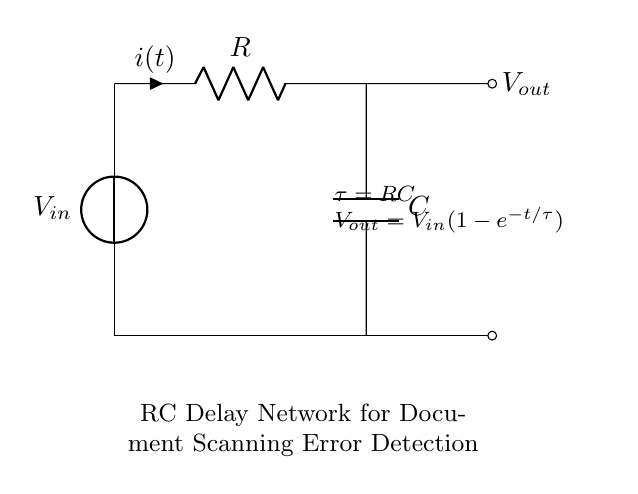What is the type of circuit shown? The circuit is an RC delay network, a combination of a resistor and a capacitor in series. This identification is made by observing the presence of a resistor and a capacitor, represented as R and C respectively, and the typical configuration used for generating a time delay.
Answer: RC delay network What is the voltage source in this circuit? The voltage source is $V_{in}$, represented at the top-left corner of the diagram. It provides the electrical energy for the circuit. The position and label clearly indicate that it is the input voltage for the circuit.
Answer: Vin What is the output voltage equation? The output voltage, as given in the circuit diagram, is $V_{out} = V_{in}(1-e^{-t/\tau})$. This expression describes the relationship between the input voltage and the output voltage over time, taking into account the resistor-capacitor time constant, which is noted in the diagram.
Answer: Vout = Vin(1-e^{-t/RC}) What does tau represent in this circuit? Tau ($\tau$) represents the time constant of the RC circuit and is given by the product of resistance (R) and capacitance (C), $\tau = RC$. This understanding comes from how the time constant affects the charging and discharging behavior of the capacitor in the circuit.
Answer: RC What happens to the output voltage as time progresses? As time progresses, the output voltage ($V_{out}$) approaches $V_{in}$. This is due to the exponential nature of capacitor charging, where $V_{out}$ rises towards $V_{in}$ over time, described by the equation provided. This behavior is integral to understanding how RC circuits operate over time.
Answer: Approaches Vin What is the direction of current flow in this circuit? The current, denoted as $i(t)$, flows from the voltage source through the resistor and into the capacitor, as indicated by the arrow on the current label. The layout of the circuit confirms this flowing direction, showing the path of least resistance for current movement.
Answer: From Vin through R to C What is the effect of increasing resistance on the time constant? Increasing resistance (R) will increase the time constant ($\tau = RC$) of the circuit. This means it will take longer for the capacitor to charge up to the maximum voltage ($V_{in}$) and discharge. The relationship between resistance and time constant is mathematical and straightforward, thereby affecting the circuit's response time.
Answer: Increases tau 